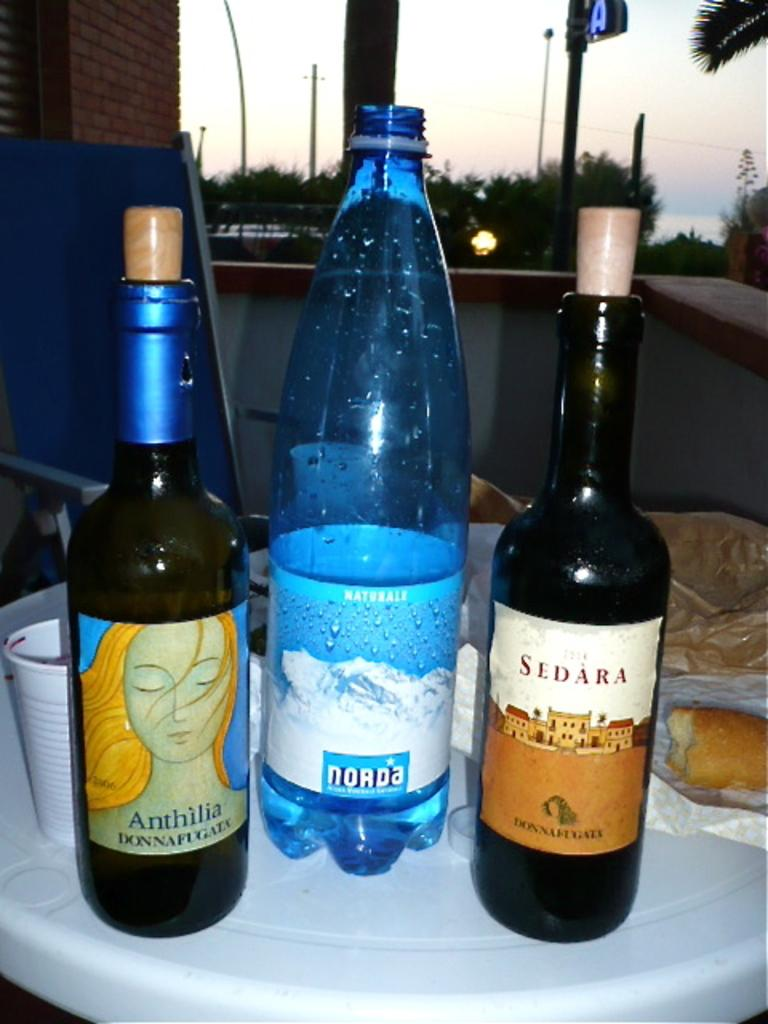Provide a one-sentence caption for the provided image. A bottle of Sedara wine and Anthilia wine are on a serving platter with water. 